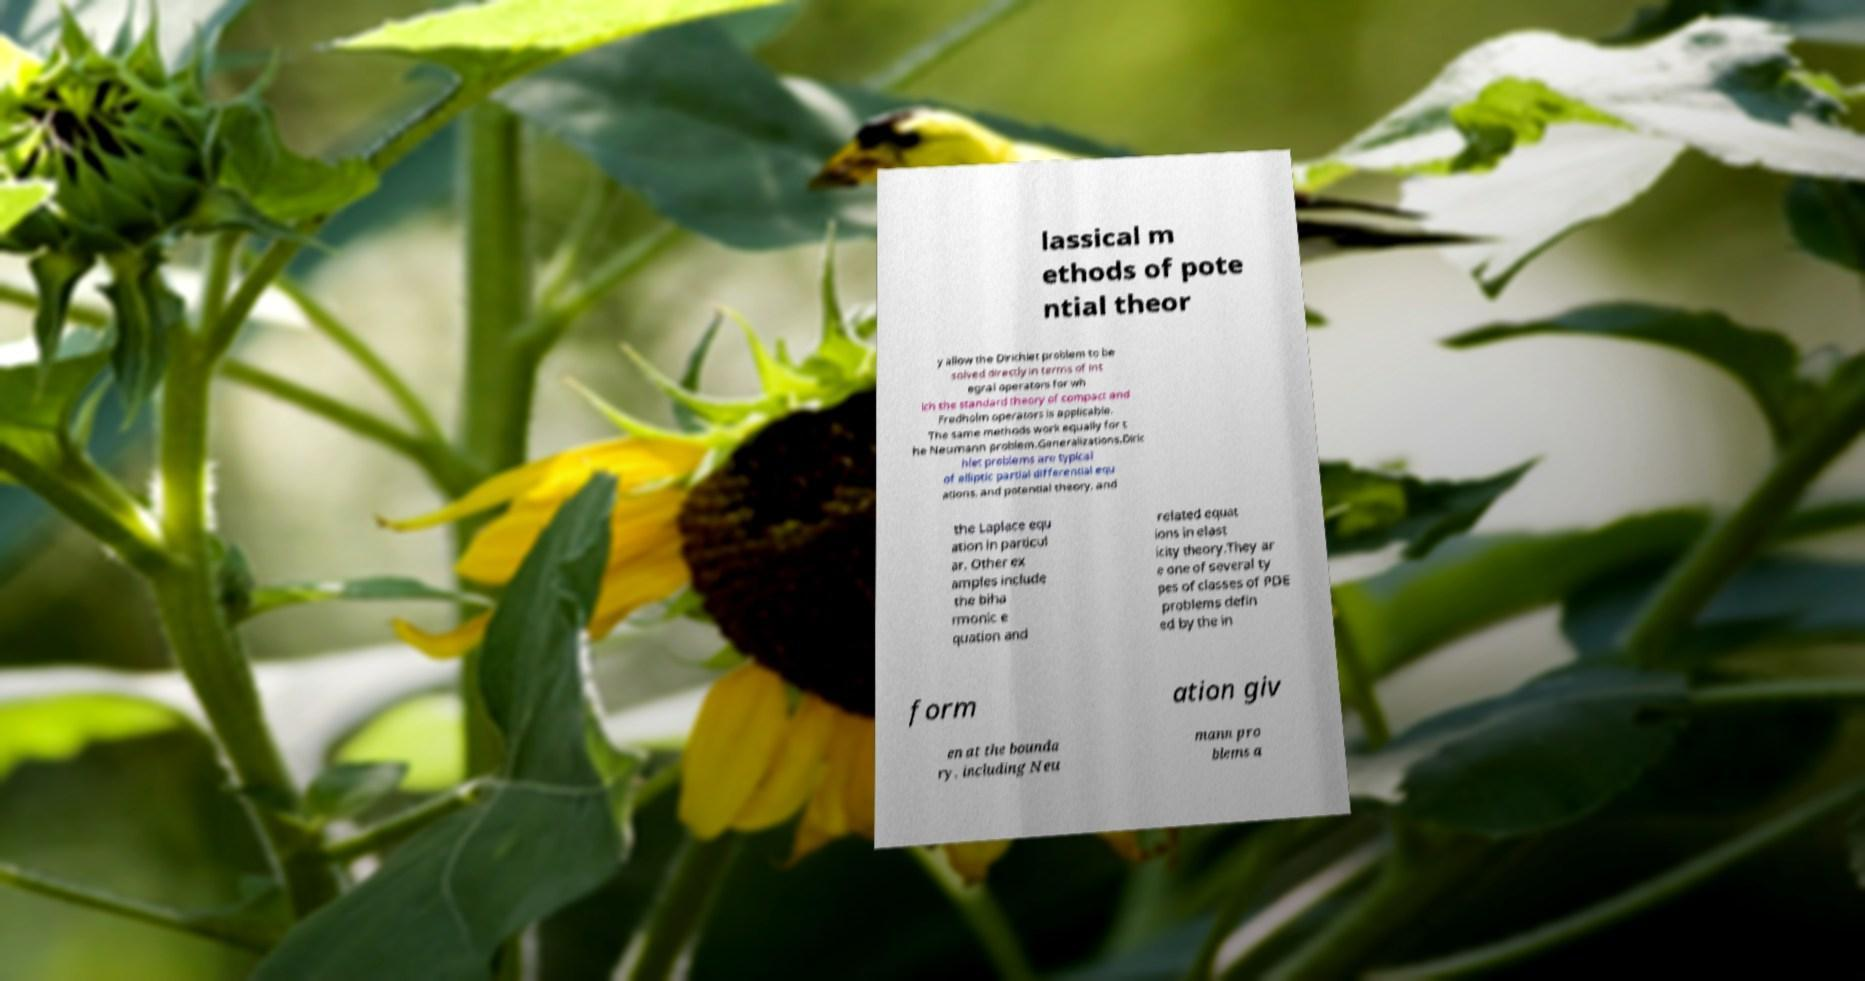There's text embedded in this image that I need extracted. Can you transcribe it verbatim? lassical m ethods of pote ntial theor y allow the Dirichlet problem to be solved directly in terms of int egral operators for wh ich the standard theory of compact and Fredholm operators is applicable. The same methods work equally for t he Neumann problem.Generalizations.Diric hlet problems are typical of elliptic partial differential equ ations, and potential theory, and the Laplace equ ation in particul ar. Other ex amples include the biha rmonic e quation and related equat ions in elast icity theory.They ar e one of several ty pes of classes of PDE problems defin ed by the in form ation giv en at the bounda ry, including Neu mann pro blems a 